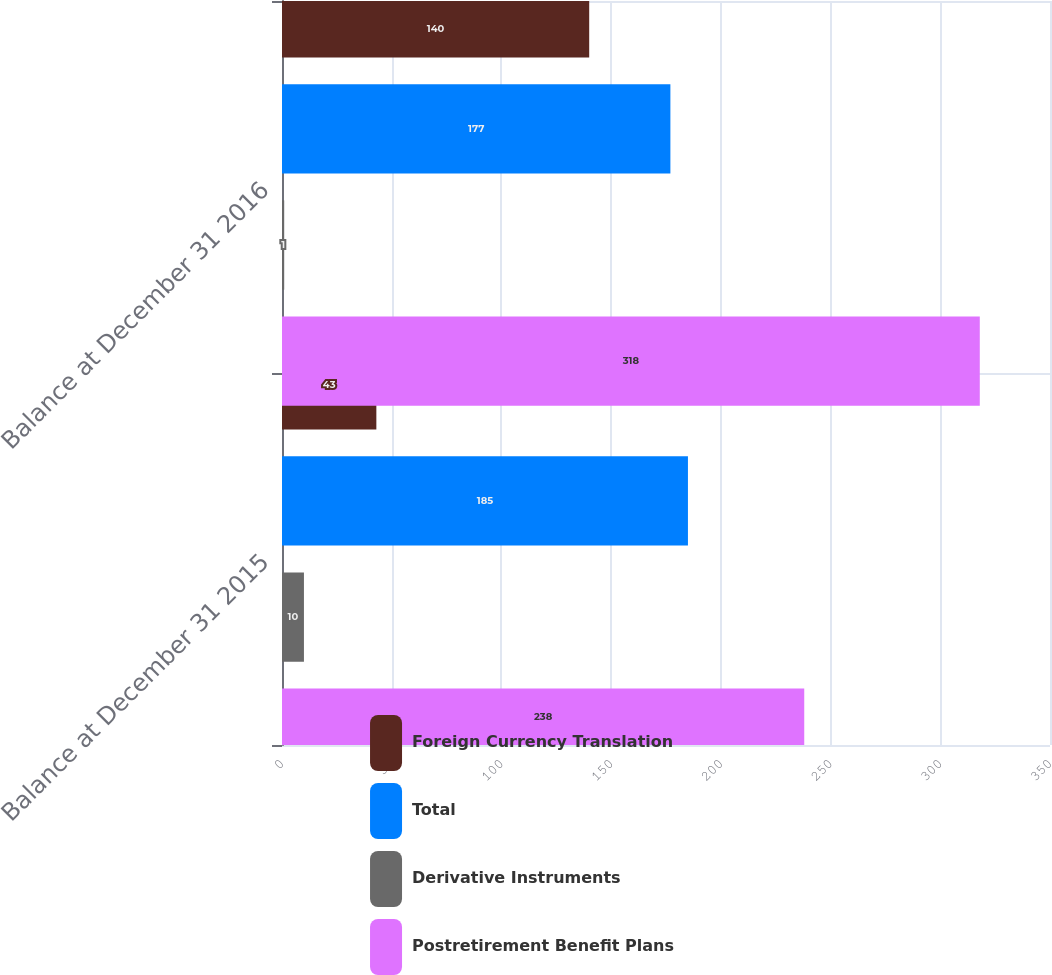Convert chart to OTSL. <chart><loc_0><loc_0><loc_500><loc_500><stacked_bar_chart><ecel><fcel>Balance at December 31 2015<fcel>Balance at December 31 2016<nl><fcel>Foreign Currency Translation<fcel>43<fcel>140<nl><fcel>Total<fcel>185<fcel>177<nl><fcel>Derivative Instruments<fcel>10<fcel>1<nl><fcel>Postretirement Benefit Plans<fcel>238<fcel>318<nl></chart> 